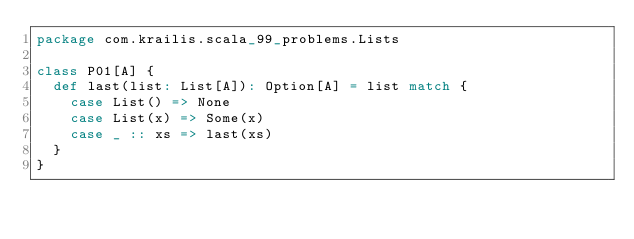Convert code to text. <code><loc_0><loc_0><loc_500><loc_500><_Scala_>package com.krailis.scala_99_problems.Lists

class P01[A] {
  def last(list: List[A]): Option[A] = list match {
    case List() => None
    case List(x) => Some(x)
    case _ :: xs => last(xs)
  }
}
</code> 